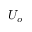Convert formula to latex. <formula><loc_0><loc_0><loc_500><loc_500>U _ { o }</formula> 